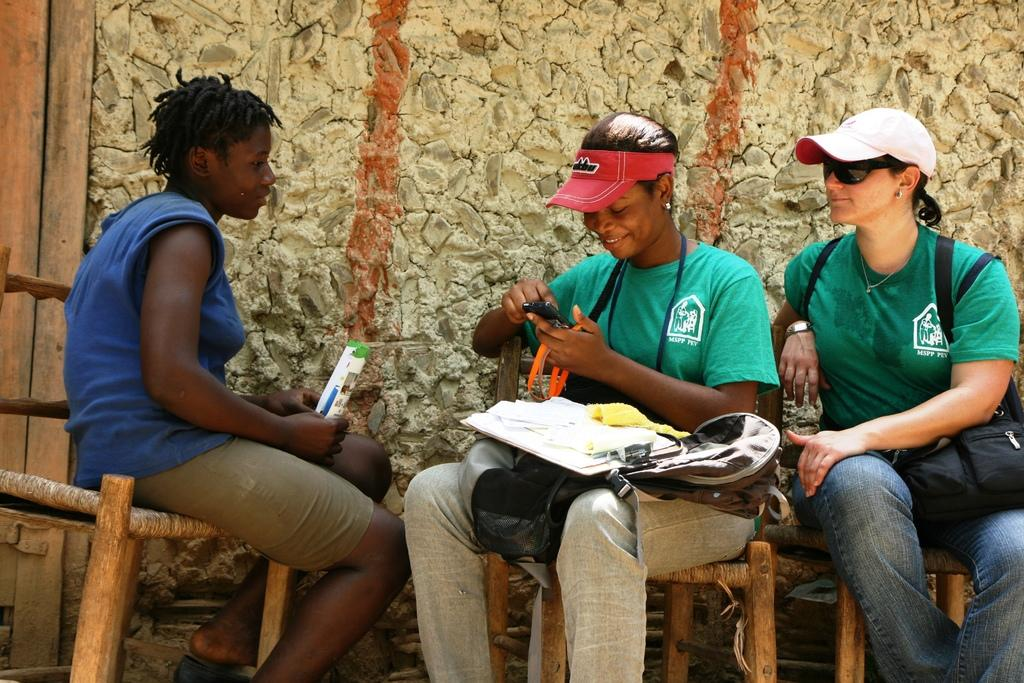What types of accessories are visible in the image? There are caps and goggles in the image. What other items can be seen in the image? There are bags, papers, a writing pad, and a mobile in the image. How many people are sitting on chairs in the image? There are three people sitting on chairs in the image. What is the facial expression of the people in the image? The people are smiling in the image. What is visible in the background of the image? There is a wall in the background of the image. What type of authority figure is present in the image? There is no authority figure present in the image. What type of balls can be seen in the image? There are no balls visible in the image. 